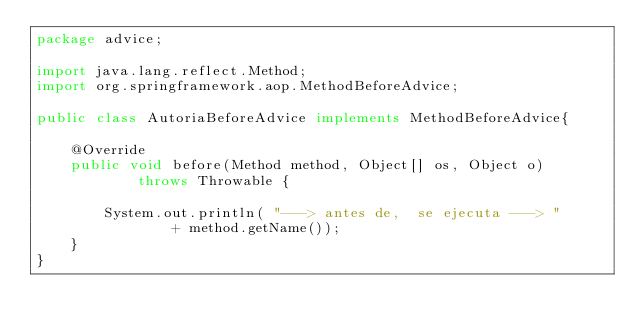<code> <loc_0><loc_0><loc_500><loc_500><_Java_>package advice;

import java.lang.reflect.Method;
import org.springframework.aop.MethodBeforeAdvice;

public class AutoriaBeforeAdvice implements MethodBeforeAdvice{

    @Override
    public void before(Method method, Object[] os, Object o) 
            throws Throwable {
        
        System.out.println( "---> antes de,  se ejecuta ---> " 
                + method.getName());
    }
}

</code> 